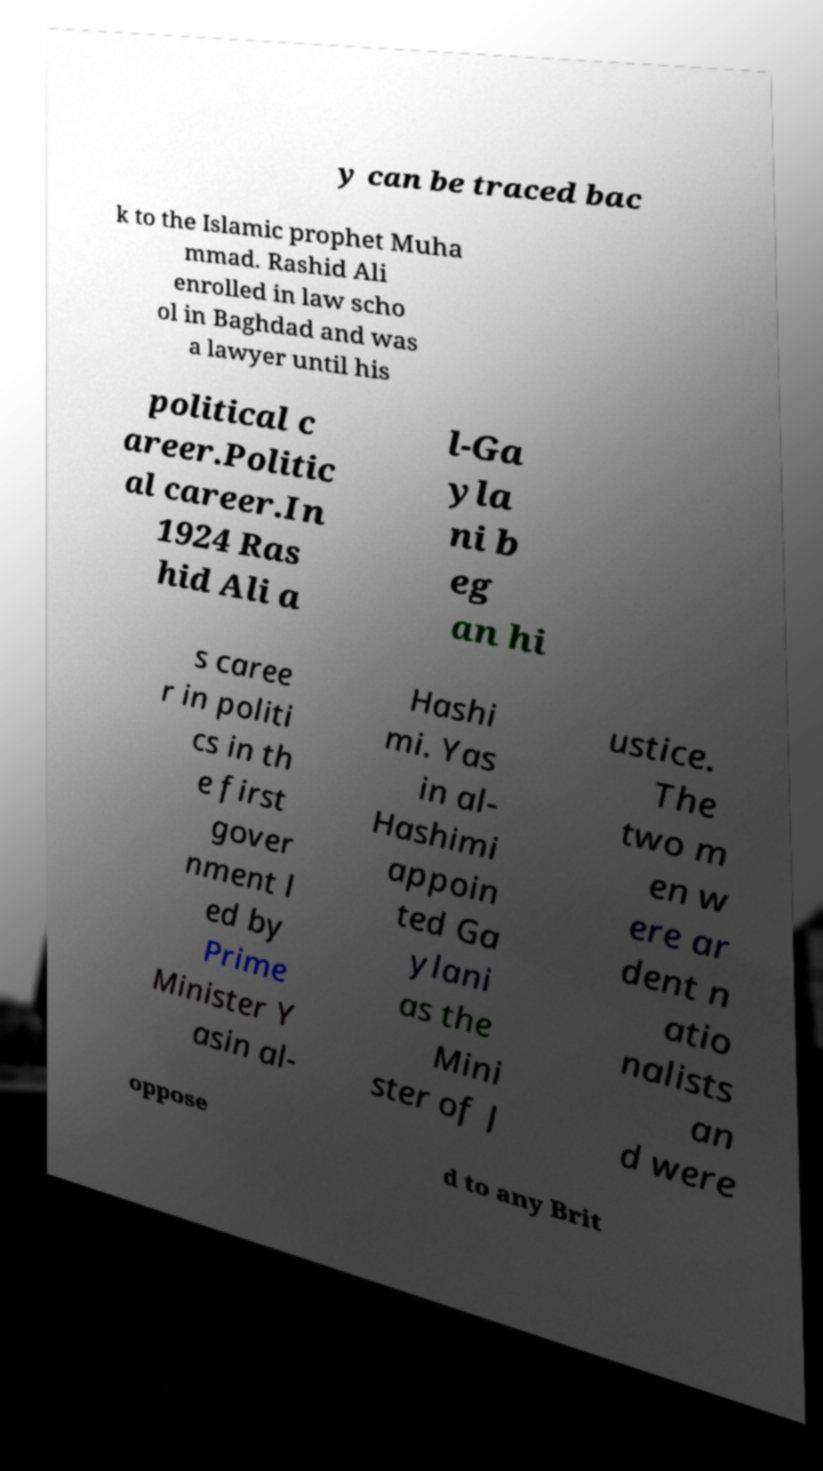Can you accurately transcribe the text from the provided image for me? y can be traced bac k to the Islamic prophet Muha mmad. Rashid Ali enrolled in law scho ol in Baghdad and was a lawyer until his political c areer.Politic al career.In 1924 Ras hid Ali a l-Ga yla ni b eg an hi s caree r in politi cs in th e first gover nment l ed by Prime Minister Y asin al- Hashi mi. Yas in al- Hashimi appoin ted Ga ylani as the Mini ster of J ustice. The two m en w ere ar dent n atio nalists an d were oppose d to any Brit 